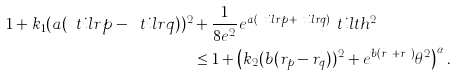<formula> <loc_0><loc_0><loc_500><loc_500>1 + k _ { 1 } ( a ( \ t i l r p - \ t i l r q ) ) ^ { 2 } & + \frac { 1 } { 8 e ^ { 2 } } e ^ { a ( \ t i l r p + \ t i l r q ) } \ t i l t h ^ { 2 } \\ & \leq 1 + \left ( k _ { 2 } ( b ( r _ { p } - r _ { q } ) ) ^ { 2 } + e ^ { b ( r _ { p } + r _ { q } ) } \theta ^ { 2 } \right ) ^ { \alpha } .</formula> 